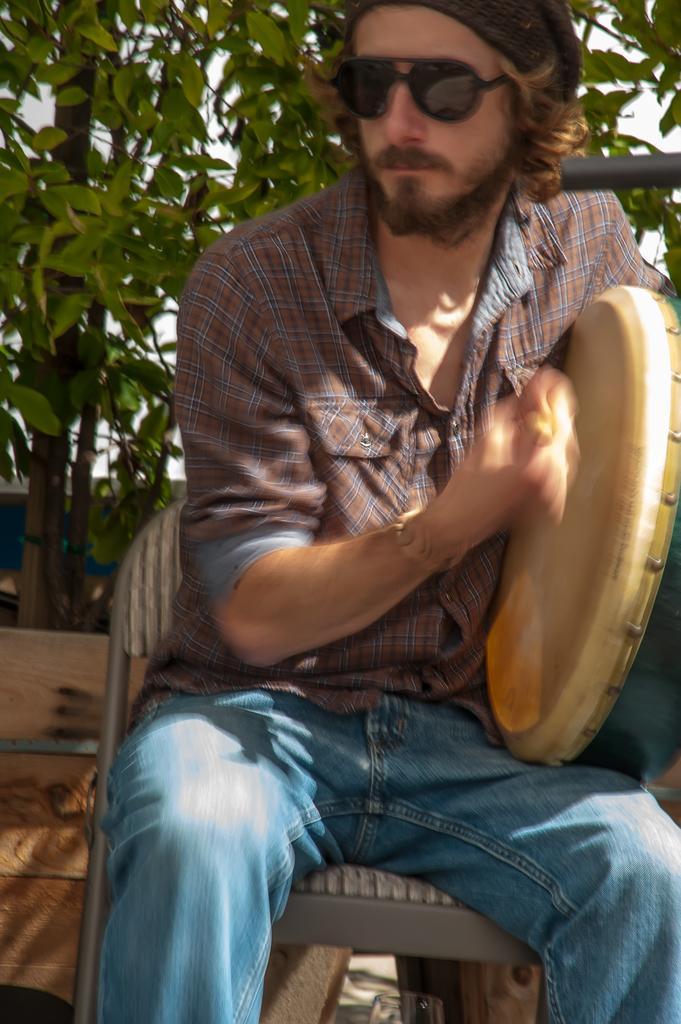Can you describe this image briefly? In the middle of the image a man is sitting and holding a musical instrument. Behind him there are some trees. 